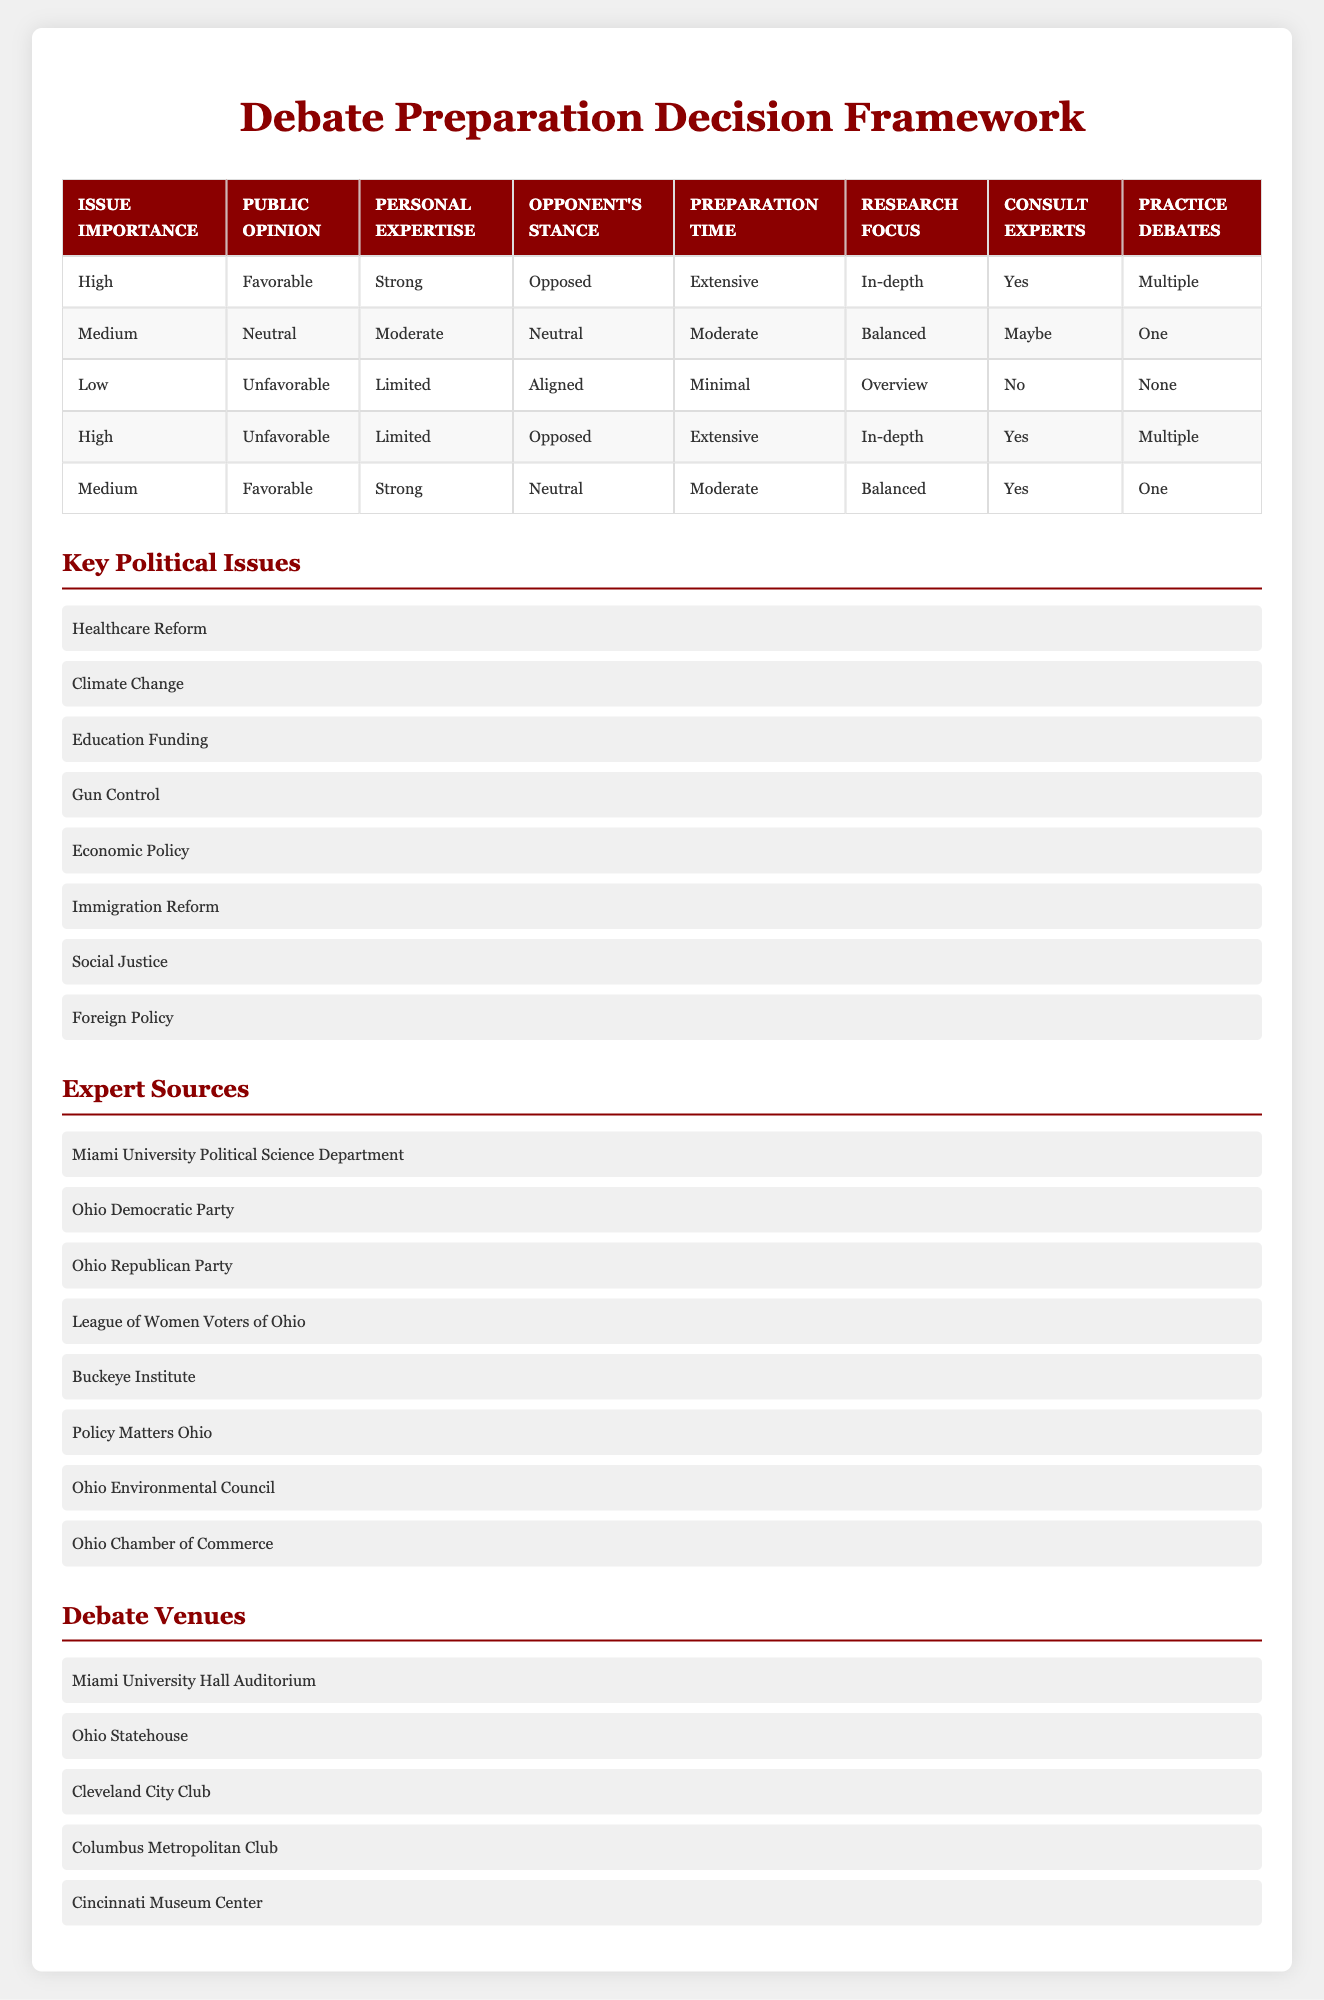What is the preparation time required for high importance issues with favorable public opinion and strong personal expertise? The rule that matches these conditions specifies preparation time as "Extensive" for the combination of "High" importance, "Favorable" public opinion, and "Strong" expertise.
Answer: Extensive Which condition indicates the need for minimal preparation time? The row containing the combination of "Low" issue importance, "Unfavorable" public opinion, "Limited" personal expertise, and "Aligned" opponent's stance states that the preparation time is "Minimal."
Answer: Low issue importance Is consulting experts necessary when the opponent's stance is neutral and public opinion is neutral? In the row that matches "Medium" issue importance, "Neutral" public opinion, "Moderate" personal expertise, and "Neutral" opponent's stance, the action specifies "Maybe," indicating that consulting experts is not a definite necessity.
Answer: No How many debate preparation actions are categorized as extensive? There are two occurrences of "Extensive" in the preparation time column: one for the rule with high importance and favorable public opinion and another for high importance with unfavorable public opinion. Therefore, the total is 2.
Answer: 2 If personal expertise is limited, what is the average preparation time category for issues with low importance and unfavorable public opinion when opponents are aligned? The relevant row shows a "Minimal" preparation time category for limited expertise, thus the average only consists of one data point: "Minimal." The average of a single category is that category itself.
Answer: Minimal What happens if the public opinion is favorable while experts are consulted? When public opinion is "Favorable" and experts are consulted, we refer to the rows with actions of consulting experts as "Yes." In total, there are three rows that correspond to favorable public opinion with expert consultation indicated.
Answer: 3 Do issues characterized by high importance and aligned opponent's stance require more research focus than those characterized by medium importance and neutral opponent's stance? The first scenario does not exist in the table. The relevant row for medium importance and neutral opponent's stance indicates "Balanced" research focus, while issues with high importance and aligned opponent's stance are not explicitly recorded. Comparing what we have, we can't conclude as there's no data on high importance with aligned stance.
Answer: Unknown How many preparation actions are classified as minimal? The rule for low importance and unfavorable public opinion leads to a preparation time of "Minimal," and that is the only row containing this classification for preparation, so there is only one minimal preparation action overall.
Answer: 1 If the opponent's stance is opposed, what percentage of the table entries recommend multiple practice debates? There are two instances of "Multiple" in the practice debates column corresponding to a stance of opposed: one with high importance and strong expertise, and the other with high importance and limited expertise. There are five rows total, so (2/5)*100 = 40%.
Answer: 40% 